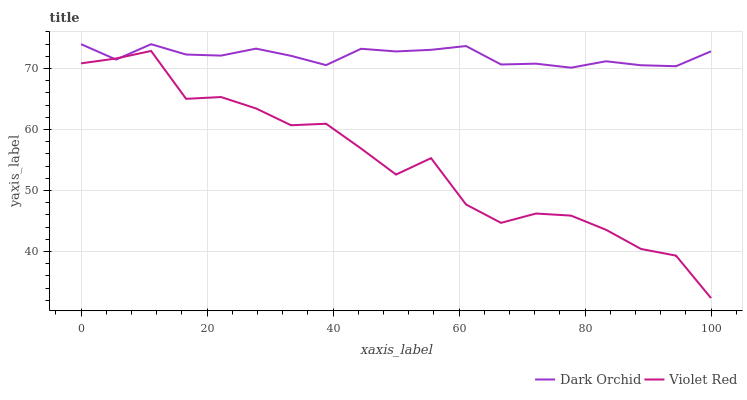Does Dark Orchid have the minimum area under the curve?
Answer yes or no. No. Is Dark Orchid the roughest?
Answer yes or no. No. Does Dark Orchid have the lowest value?
Answer yes or no. No. 